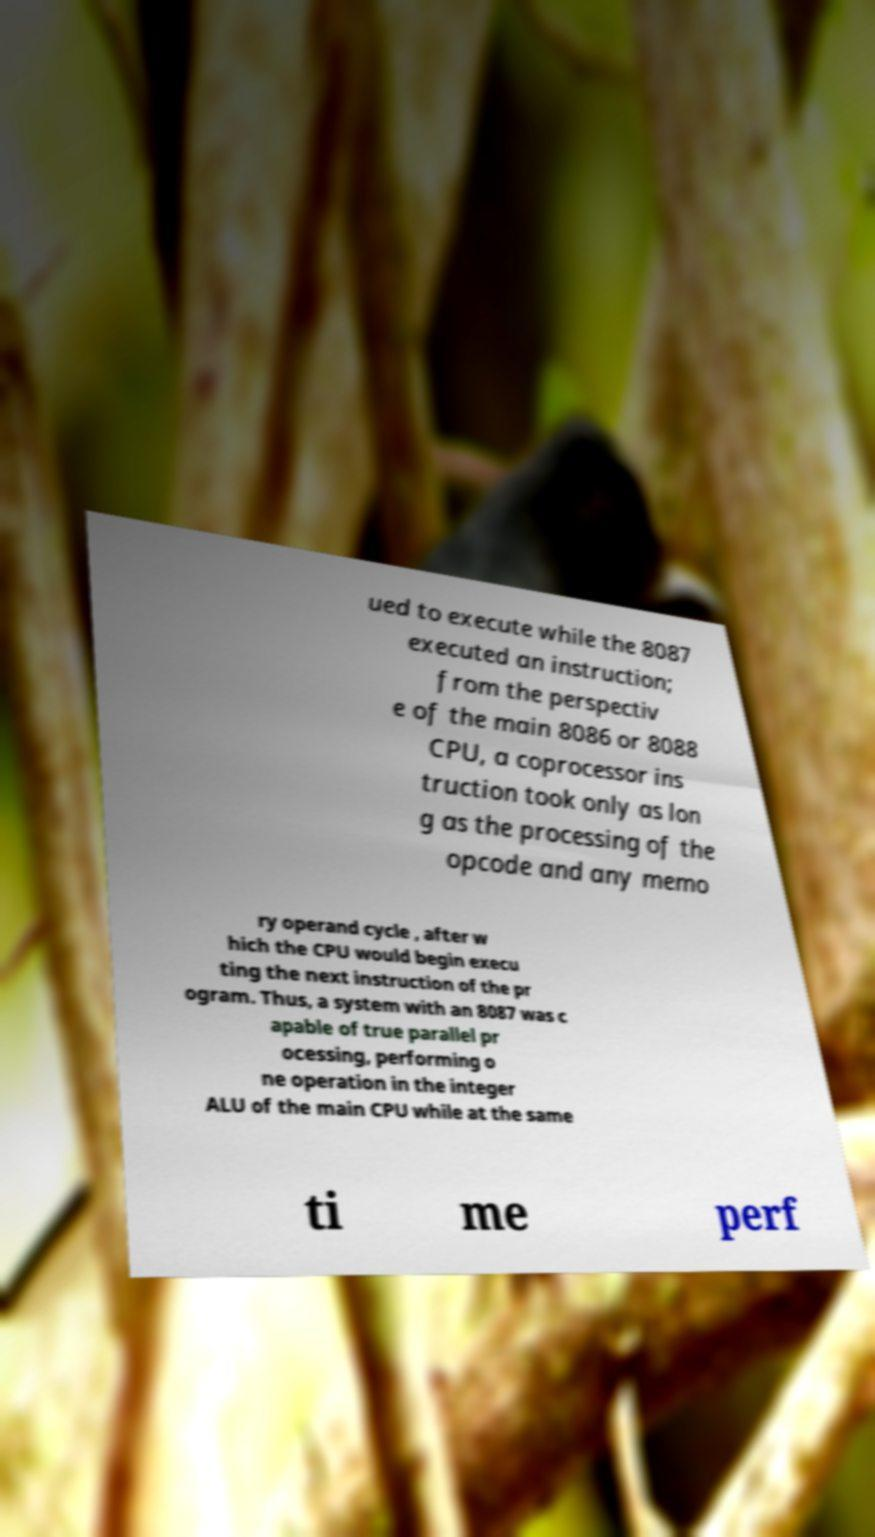Please identify and transcribe the text found in this image. ued to execute while the 8087 executed an instruction; from the perspectiv e of the main 8086 or 8088 CPU, a coprocessor ins truction took only as lon g as the processing of the opcode and any memo ry operand cycle , after w hich the CPU would begin execu ting the next instruction of the pr ogram. Thus, a system with an 8087 was c apable of true parallel pr ocessing, performing o ne operation in the integer ALU of the main CPU while at the same ti me perf 